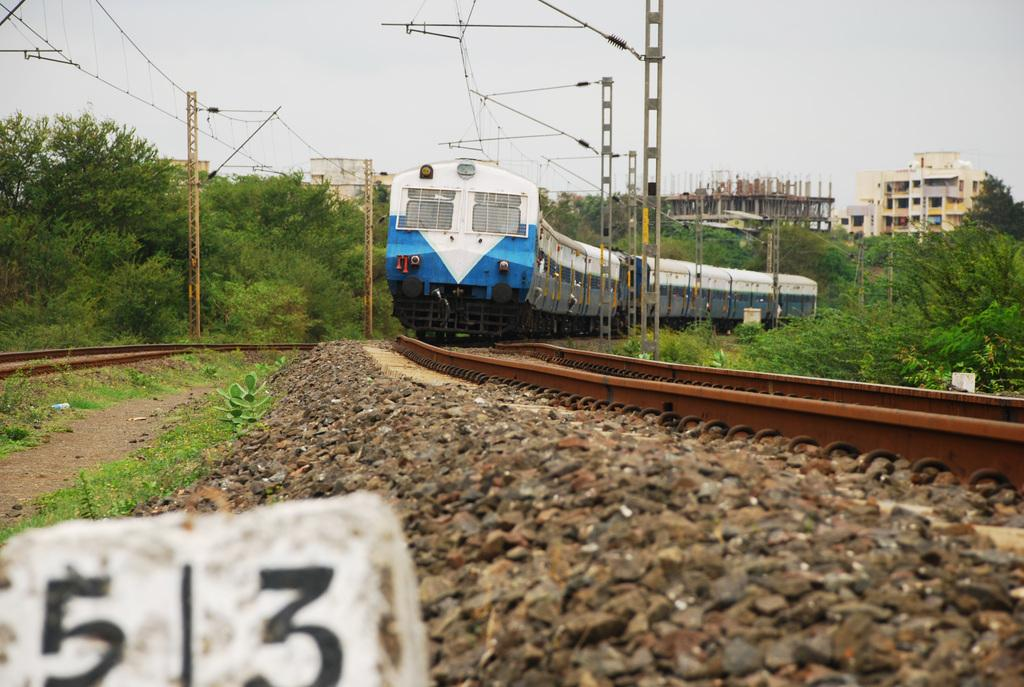What is the main subject of the image? The main subject of the image is a train. Where is the train located in the image? The train is on a railway track. What can be seen in the background of the image? Trees, poles, wires, buildings, and small stones are visible in the image. What is the color of the sky in the image? The sky is visible in the image, and its color is a combination of white and blue. What type of fowl can be seen making a humorous business deal in the image? There is no fowl or business deal present in the image; it features a train on a railway track with various background elements. 